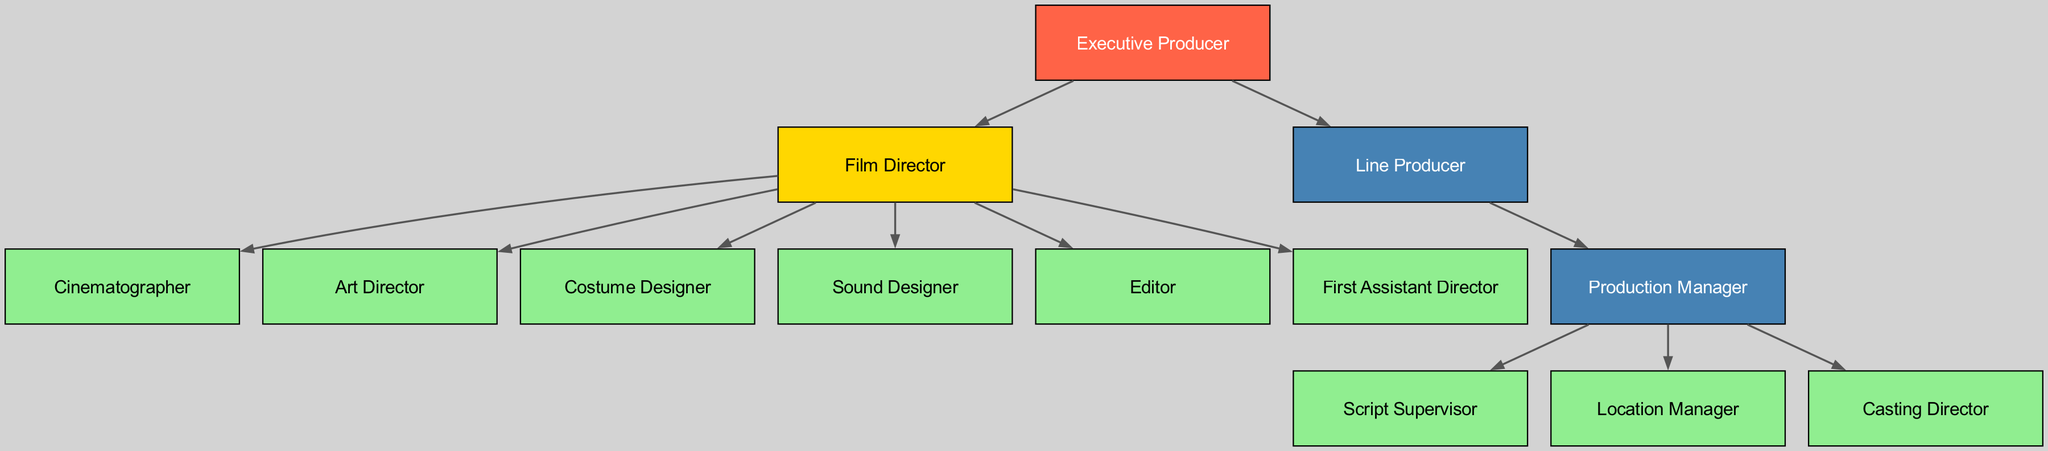What is the topmost role in the hierarchy? The topmost role is represented by the first node at the uppermost position of the diagram, which is the Executive Producer.
Answer: Executive Producer How many total nodes are present in the diagram? To find the total nodes, count each distinct role labeled in the diagram. There are 13 unique roles listed.
Answer: 13 Which role directly reports to the Film Director? The edges originating from the Film Director show all roles that report directly to them, and one of those roles is the Cinematographer.
Answer: Cinematographer Who is the direct report of the Line Producer? The diagram indicates that the Production Manager is the role that reports directly to the Line Producer.
Answer: Production Manager What color represents the Film Director in the graph? By examining the node color assigned to the Film Director in the diagram, we find it is filled with a golden color.
Answer: Golden Which roles report to the Production Manager? By analyzing the edges connected to the Production Manager, we see that there are three roles branching from it: Script Supervisor, Location Manager, and Casting Director.
Answer: Script Supervisor, Location Manager, Casting Director How many edges emanate from the Film Director? We determine the number of outgoing edges from the Film Director by counting how many roles it reports to, which amounts to 5.
Answer: 5 What is the relationship between the Executive Producer and the Film Director? The relationship is a direct reporting line where the Film Director reports to the Executive Producer as indicated by the directed edge from Executive Producer to Film Director.
Answer: Direct report Which role has the highest level of responsibility in this hierarchy? The highest level of responsibility is attributed to the Executive Producer, as they are at the top of the hierarchy and oversee the Film Director and Line Producer.
Answer: Executive Producer 